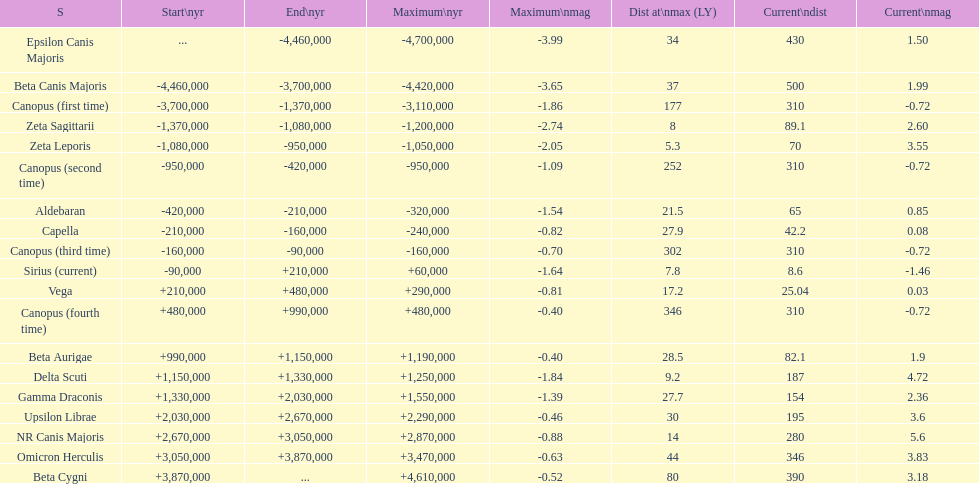How many stars have a current magnitude of at least 1.0? 11. Would you mind parsing the complete table? {'header': ['S', 'Start\\nyr', 'End\\nyr', 'Maximum\\nyr', 'Maximum\\nmag', 'Dist at\\nmax (LY)', 'Current\\ndist', 'Current\\nmag'], 'rows': [['Epsilon Canis Majoris', '...', '-4,460,000', '-4,700,000', '-3.99', '34', '430', '1.50'], ['Beta Canis Majoris', '-4,460,000', '-3,700,000', '-4,420,000', '-3.65', '37', '500', '1.99'], ['Canopus (first time)', '-3,700,000', '-1,370,000', '-3,110,000', '-1.86', '177', '310', '-0.72'], ['Zeta Sagittarii', '-1,370,000', '-1,080,000', '-1,200,000', '-2.74', '8', '89.1', '2.60'], ['Zeta Leporis', '-1,080,000', '-950,000', '-1,050,000', '-2.05', '5.3', '70', '3.55'], ['Canopus (second time)', '-950,000', '-420,000', '-950,000', '-1.09', '252', '310', '-0.72'], ['Aldebaran', '-420,000', '-210,000', '-320,000', '-1.54', '21.5', '65', '0.85'], ['Capella', '-210,000', '-160,000', '-240,000', '-0.82', '27.9', '42.2', '0.08'], ['Canopus (third time)', '-160,000', '-90,000', '-160,000', '-0.70', '302', '310', '-0.72'], ['Sirius (current)', '-90,000', '+210,000', '+60,000', '-1.64', '7.8', '8.6', '-1.46'], ['Vega', '+210,000', '+480,000', '+290,000', '-0.81', '17.2', '25.04', '0.03'], ['Canopus (fourth time)', '+480,000', '+990,000', '+480,000', '-0.40', '346', '310', '-0.72'], ['Beta Aurigae', '+990,000', '+1,150,000', '+1,190,000', '-0.40', '28.5', '82.1', '1.9'], ['Delta Scuti', '+1,150,000', '+1,330,000', '+1,250,000', '-1.84', '9.2', '187', '4.72'], ['Gamma Draconis', '+1,330,000', '+2,030,000', '+1,550,000', '-1.39', '27.7', '154', '2.36'], ['Upsilon Librae', '+2,030,000', '+2,670,000', '+2,290,000', '-0.46', '30', '195', '3.6'], ['NR Canis Majoris', '+2,670,000', '+3,050,000', '+2,870,000', '-0.88', '14', '280', '5.6'], ['Omicron Herculis', '+3,050,000', '+3,870,000', '+3,470,000', '-0.63', '44', '346', '3.83'], ['Beta Cygni', '+3,870,000', '...', '+4,610,000', '-0.52', '80', '390', '3.18']]} 